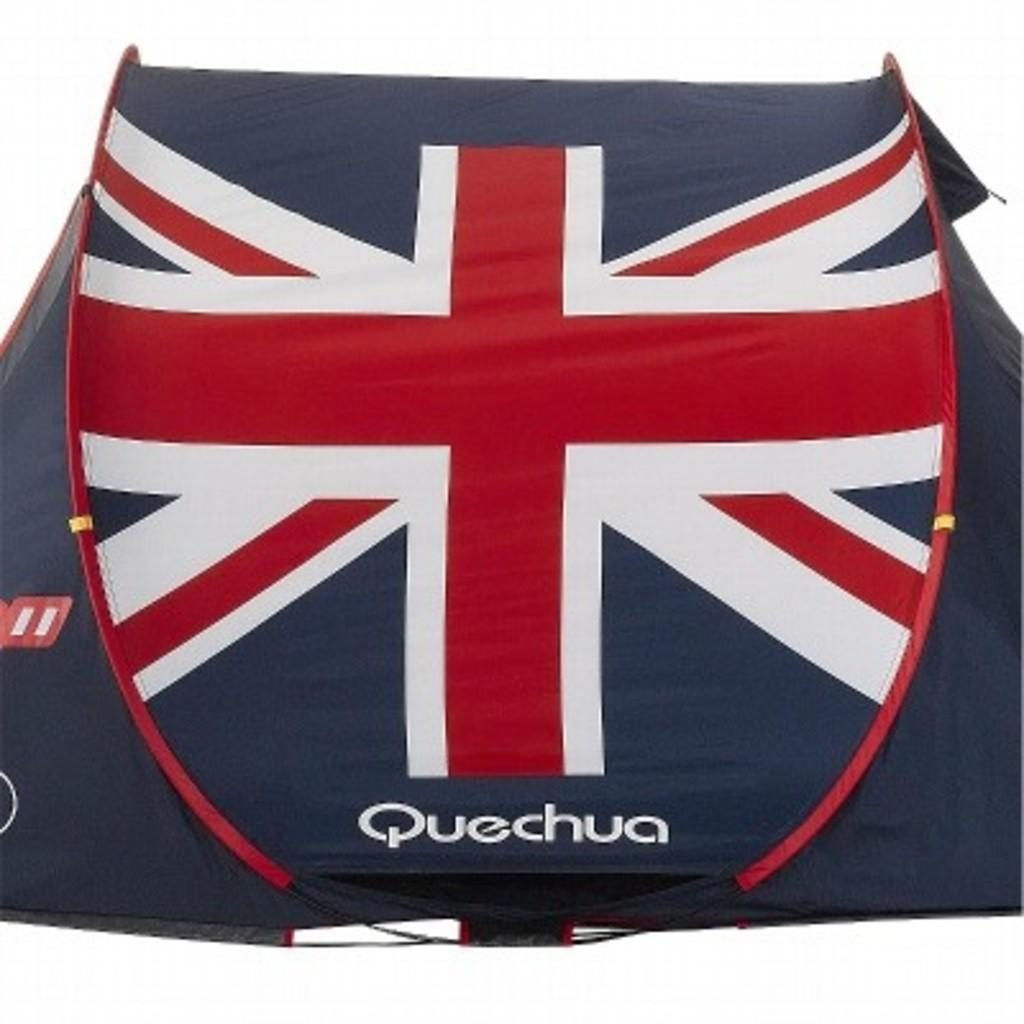What is the main color of the object in the image? The main color of the object in the image is black. What additional colors can be seen on the black object? The black object has red and white lines on it. Is there any text present on the black object? Yes, there is text written on the black object. What is the color of the background in the image? The background of the image is white. Reasoning: Let'ing: Let's think step by step in order to produce the conversation. We start by identifying the main color of the object in the image, which is black. Then, we describe the additional colors and text present on the black object. Finally, we mention the color of the background, which is white. Each question is designed to elicit a specific detail about the image that is known from the provided facts. Absurd Question/Answer: Can you tell me how many bees are buzzing around the black object in the image? There are no bees present in the image. What emotion is the black object displaying in the image? The black object is an inanimate object and does not display emotions like anger. Can you tell me how many cattle are grazing in the background of the image? There are no cattle present in the image; the background is white. What type of creature is shown interacting with the black object in the image? There is no creature shown interacting with the black object in the image; it is stationary with red and white lines and text written on it. 